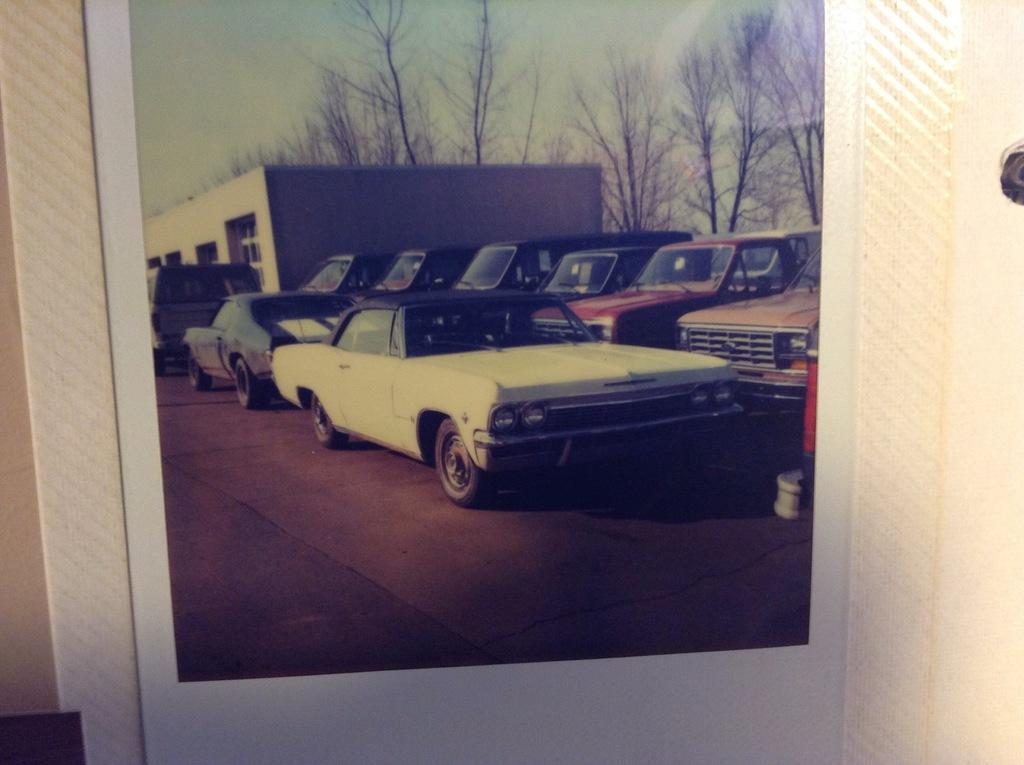What object is present in the image that typically holds a picture? There is a picture frame in the image. What is depicted in the picture frame? The picture frame contains a picture of a house. What type of natural environment can be seen in the picture? There are trees in the picture. How many cars are visible in the image? There are many cars in the picture. What type of impulse can be seen affecting the house in the picture? There is no impulse affecting the house in the picture; it is a static image of a house. What is the weight of the playground equipment visible in the image? There is no playground equipment visible in the image; it features a picture frame with a picture of a house and trees. 